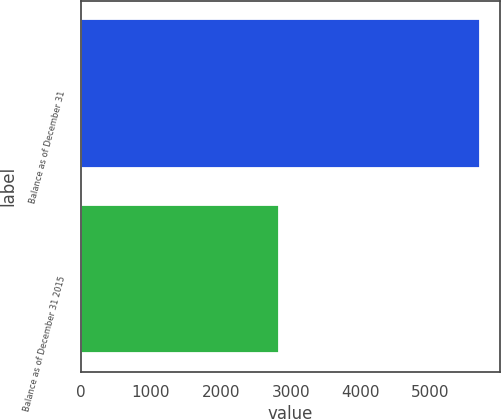<chart> <loc_0><loc_0><loc_500><loc_500><bar_chart><fcel>Balance as of December 31<fcel>Balance as of December 31 2015<nl><fcel>5712<fcel>2840<nl></chart> 